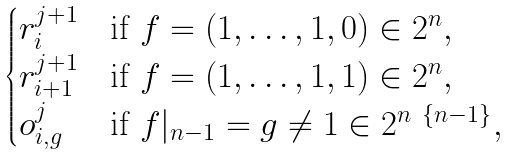Convert formula to latex. <formula><loc_0><loc_0><loc_500><loc_500>\begin{cases} r _ { i } ^ { j + 1 } & \text {if } f = ( 1 , \dots , 1 , 0 ) \in 2 ^ { n } , \\ r _ { i + 1 } ^ { j + 1 } & \text {if } f = ( 1 , \dots , 1 , 1 ) \in 2 ^ { n } , \\ o ^ { j } _ { i , g } & \text {if } f | _ { n - 1 } = g \neq 1 \in 2 ^ { n \ \{ n - 1 \} } , \end{cases}</formula> 